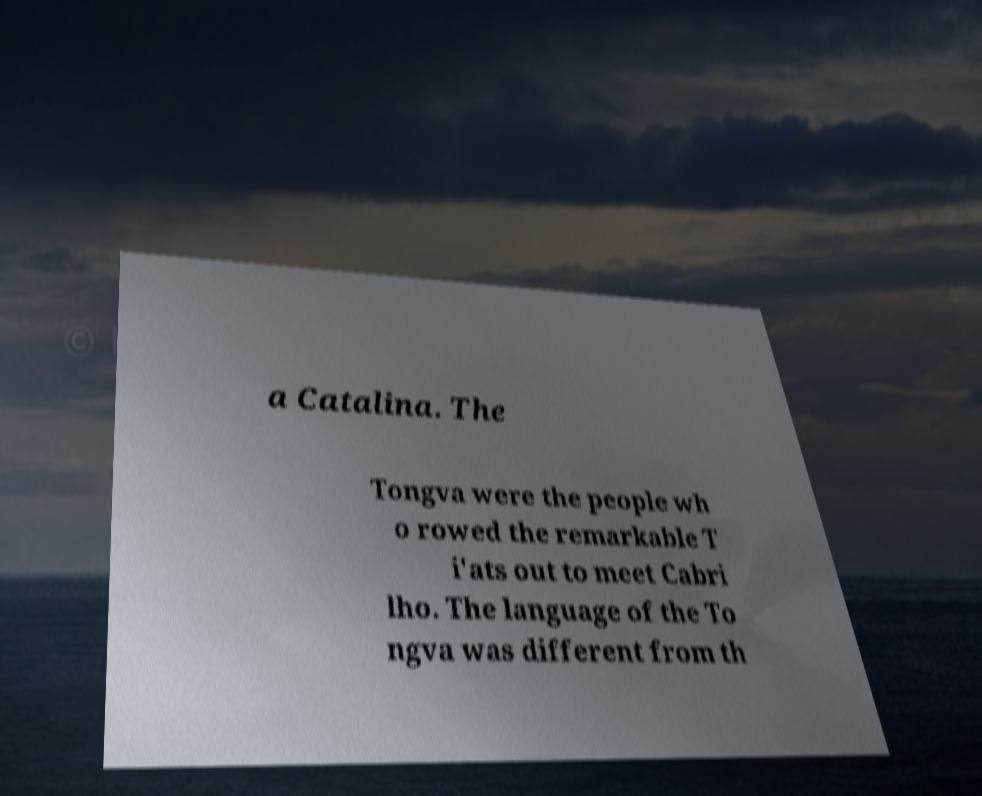Please identify and transcribe the text found in this image. a Catalina. The Tongva were the people wh o rowed the remarkable T i'ats out to meet Cabri lho. The language of the To ngva was different from th 